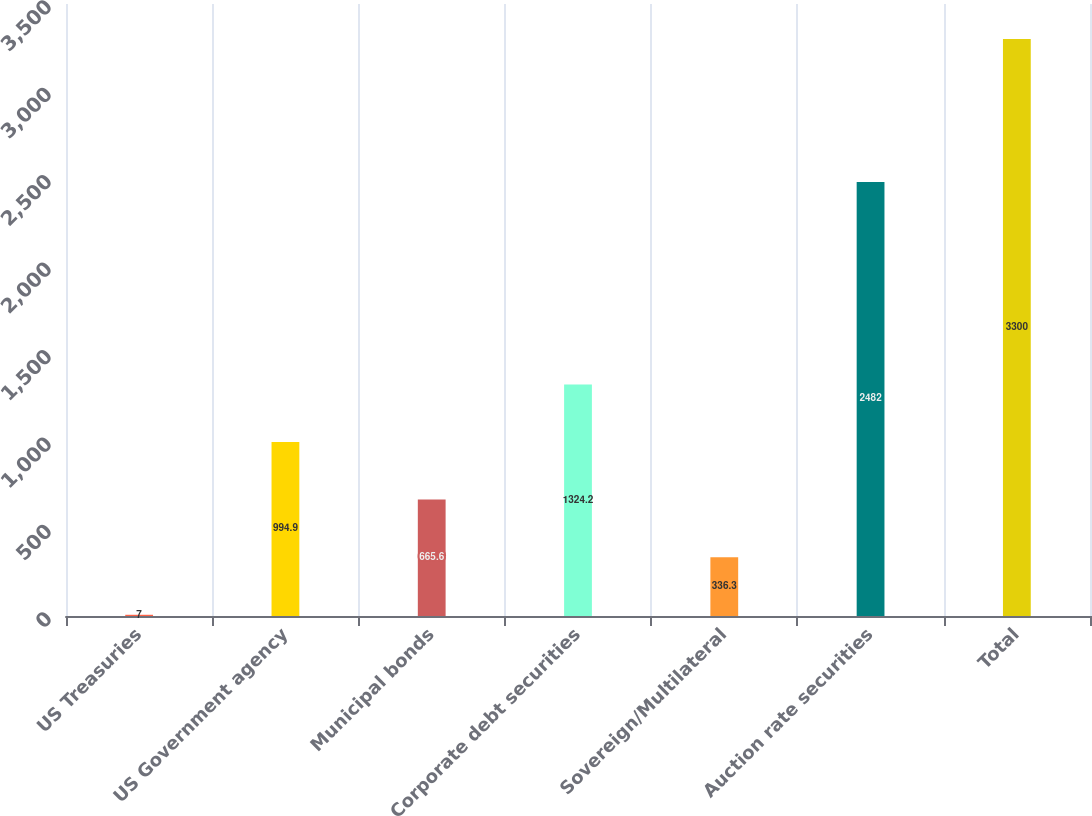Convert chart to OTSL. <chart><loc_0><loc_0><loc_500><loc_500><bar_chart><fcel>US Treasuries<fcel>US Government agency<fcel>Municipal bonds<fcel>Corporate debt securities<fcel>Sovereign/Multilateral<fcel>Auction rate securities<fcel>Total<nl><fcel>7<fcel>994.9<fcel>665.6<fcel>1324.2<fcel>336.3<fcel>2482<fcel>3300<nl></chart> 